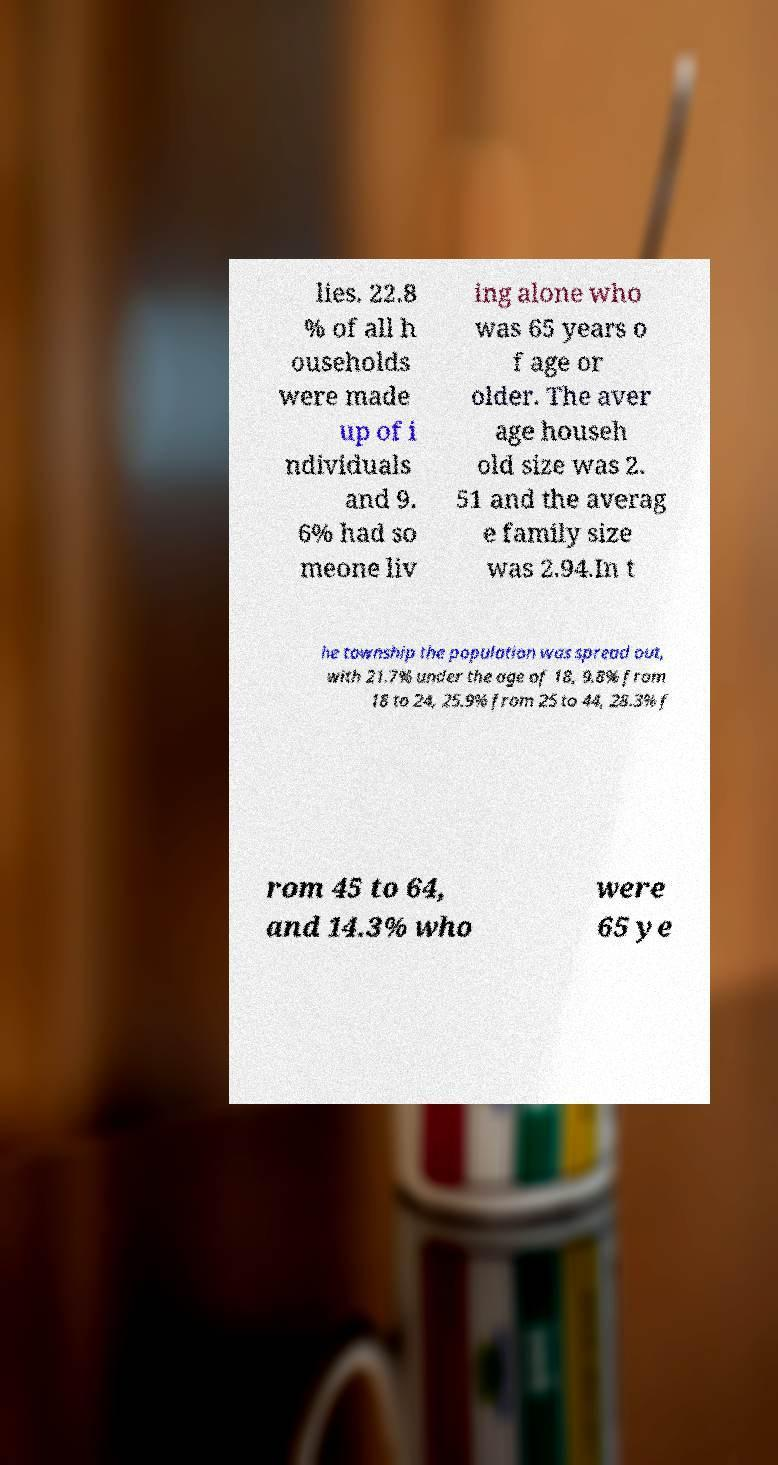There's text embedded in this image that I need extracted. Can you transcribe it verbatim? lies. 22.8 % of all h ouseholds were made up of i ndividuals and 9. 6% had so meone liv ing alone who was 65 years o f age or older. The aver age househ old size was 2. 51 and the averag e family size was 2.94.In t he township the population was spread out, with 21.7% under the age of 18, 9.8% from 18 to 24, 25.9% from 25 to 44, 28.3% f rom 45 to 64, and 14.3% who were 65 ye 